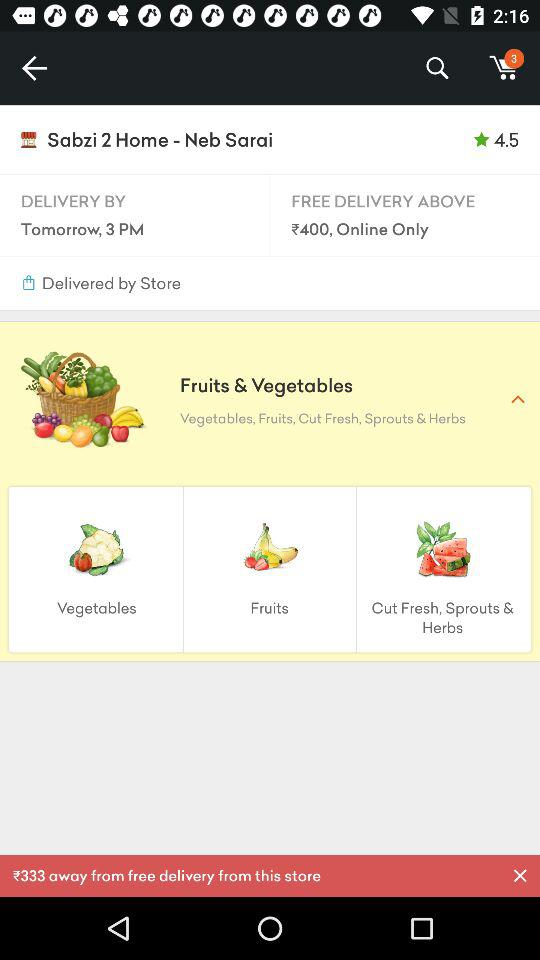What is the price after which it will be free delivery? The price after which it will be free delivery is ₹400. 